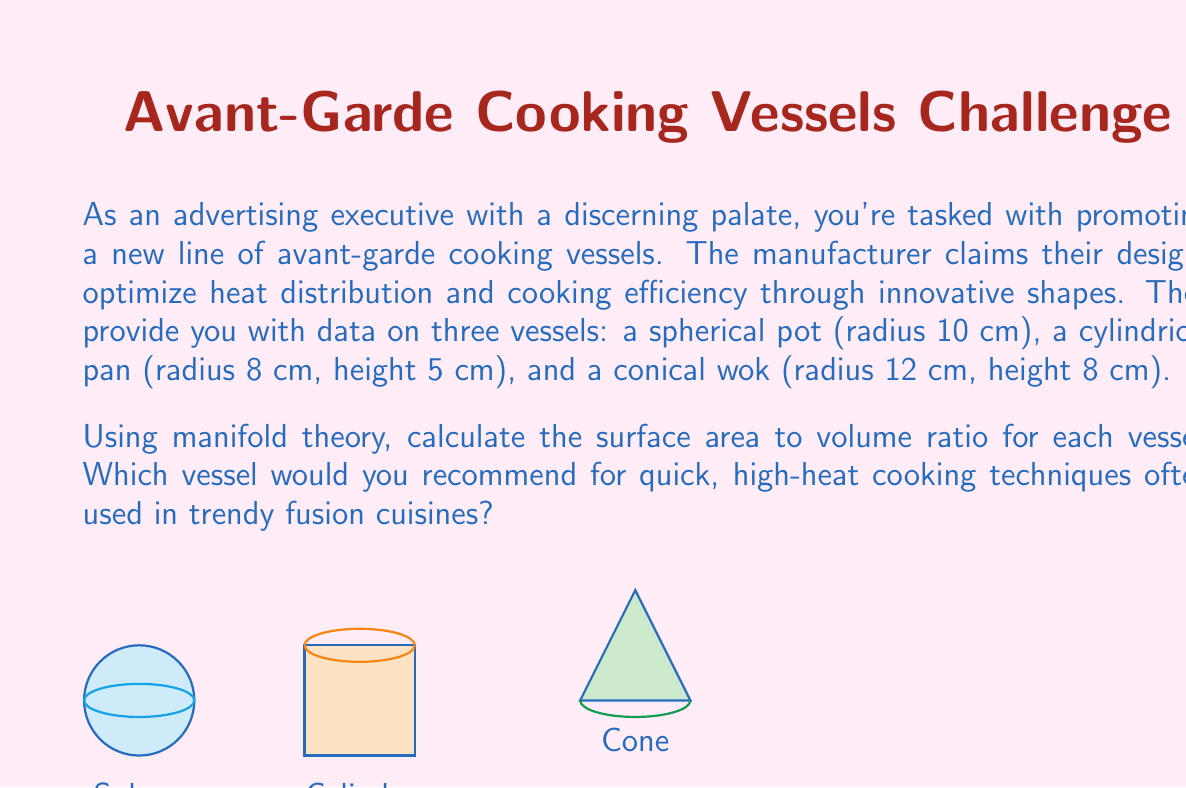Teach me how to tackle this problem. Let's approach this step-by-step using manifold theory:

1) For a sphere:
   Surface area: $A_s = 4\pi r^2$
   Volume: $V_s = \frac{4}{3}\pi r^3$
   Ratio: $\frac{A_s}{V_s} = \frac{3}{r}$
   
   With $r = 10$ cm:
   $\frac{A_s}{V_s} = \frac{3}{10} = 0.3$ cm^(-1)

2) For a cylinder:
   Surface area: $A_c = 2\pi r^2 + 2\pi rh$
   Volume: $V_c = \pi r^2 h$
   Ratio: $\frac{A_c}{V_c} = \frac{2}{r} + \frac{2}{h}$
   
   With $r = 8$ cm, $h = 5$ cm:
   $\frac{A_c}{V_c} = \frac{2}{8} + \frac{2}{5} = 0.25 + 0.4 = 0.65$ cm^(-1)

3) For a cone:
   Surface area: $A_n = \pi r^2 + \pi r\sqrt{r^2 + h^2}$
   Volume: $V_n = \frac{1}{3}\pi r^2 h$
   Ratio: $\frac{A_n}{V_n} = \frac{3}{h} + \frac{3\sqrt{r^2 + h^2}}{rh}$
   
   With $r = 12$ cm, $h = 8$ cm:
   $\frac{A_n}{V_n} = \frac{3}{8} + \frac{3\sqrt{12^2 + 8^2}}{12 * 8} \approx 0.375 + 0.325 = 0.7$ cm^(-1)

From a manifold perspective, these ratios represent the relationship between the 2-dimensional boundary manifold (surface area) and the 3-dimensional manifold with boundary (volume) for each vessel.

The vessel with the highest surface area to volume ratio will allow for the quickest heat transfer and most efficient cooking for high-heat techniques.
Answer: The conical wok, with a ratio of approximately 0.7 cm^(-1), has the highest surface area to volume ratio and would be most suitable for quick, high-heat cooking techniques in trendy fusion cuisines. 